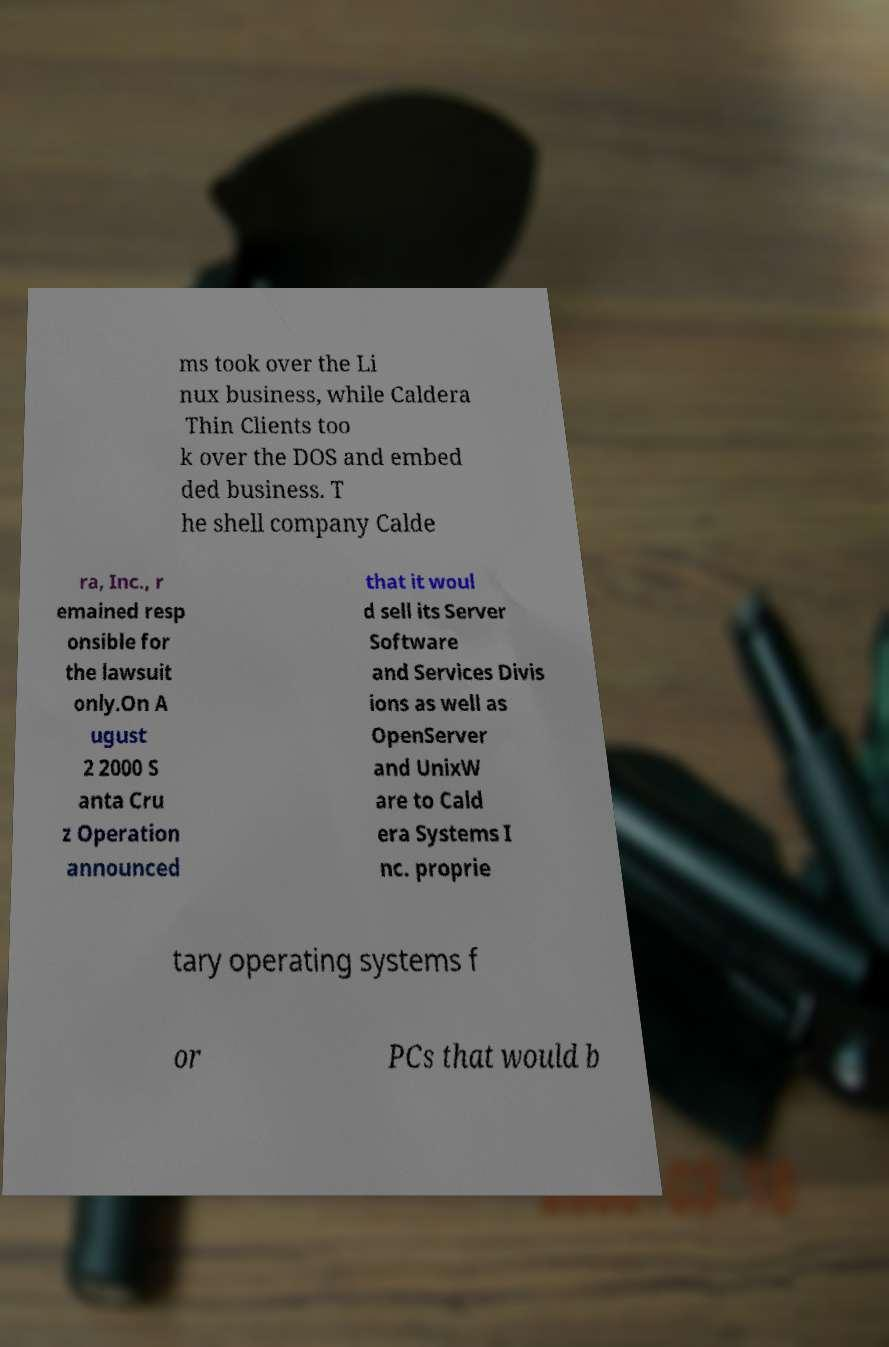Can you read and provide the text displayed in the image?This photo seems to have some interesting text. Can you extract and type it out for me? ms took over the Li nux business, while Caldera Thin Clients too k over the DOS and embed ded business. T he shell company Calde ra, Inc., r emained resp onsible for the lawsuit only.On A ugust 2 2000 S anta Cru z Operation announced that it woul d sell its Server Software and Services Divis ions as well as OpenServer and UnixW are to Cald era Systems I nc. proprie tary operating systems f or PCs that would b 